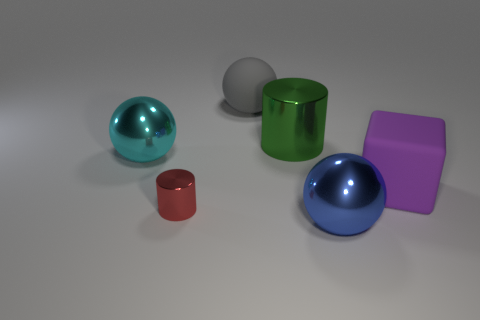Is the number of tiny metallic cylinders that are behind the tiny red thing less than the number of blue metallic things?
Offer a very short reply. Yes. Is there any other thing that is the same shape as the big purple object?
Your response must be concise. No. Are there any tiny cyan objects?
Offer a terse response. No. Is the number of red cylinders less than the number of gray metallic things?
Your answer should be very brief. No. How many big purple objects are made of the same material as the large gray object?
Your response must be concise. 1. There is a big sphere that is the same material as the cyan object; what is its color?
Provide a short and direct response. Blue. What shape is the green metal object?
Your response must be concise. Cylinder. How many tiny things are the same color as the cube?
Provide a short and direct response. 0. What shape is the blue metallic thing that is the same size as the cyan object?
Give a very brief answer. Sphere. Are there any gray objects that have the same size as the blue metallic sphere?
Ensure brevity in your answer.  Yes. 